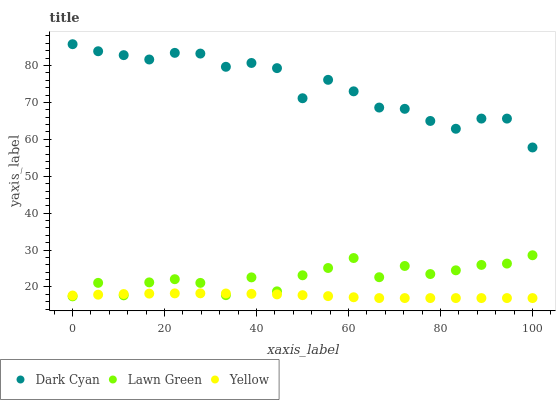Does Yellow have the minimum area under the curve?
Answer yes or no. Yes. Does Dark Cyan have the maximum area under the curve?
Answer yes or no. Yes. Does Lawn Green have the minimum area under the curve?
Answer yes or no. No. Does Lawn Green have the maximum area under the curve?
Answer yes or no. No. Is Yellow the smoothest?
Answer yes or no. Yes. Is Lawn Green the roughest?
Answer yes or no. Yes. Is Lawn Green the smoothest?
Answer yes or no. No. Is Yellow the roughest?
Answer yes or no. No. Does Yellow have the lowest value?
Answer yes or no. Yes. Does Lawn Green have the lowest value?
Answer yes or no. No. Does Dark Cyan have the highest value?
Answer yes or no. Yes. Does Lawn Green have the highest value?
Answer yes or no. No. Is Yellow less than Dark Cyan?
Answer yes or no. Yes. Is Dark Cyan greater than Yellow?
Answer yes or no. Yes. Does Lawn Green intersect Yellow?
Answer yes or no. Yes. Is Lawn Green less than Yellow?
Answer yes or no. No. Is Lawn Green greater than Yellow?
Answer yes or no. No. Does Yellow intersect Dark Cyan?
Answer yes or no. No. 